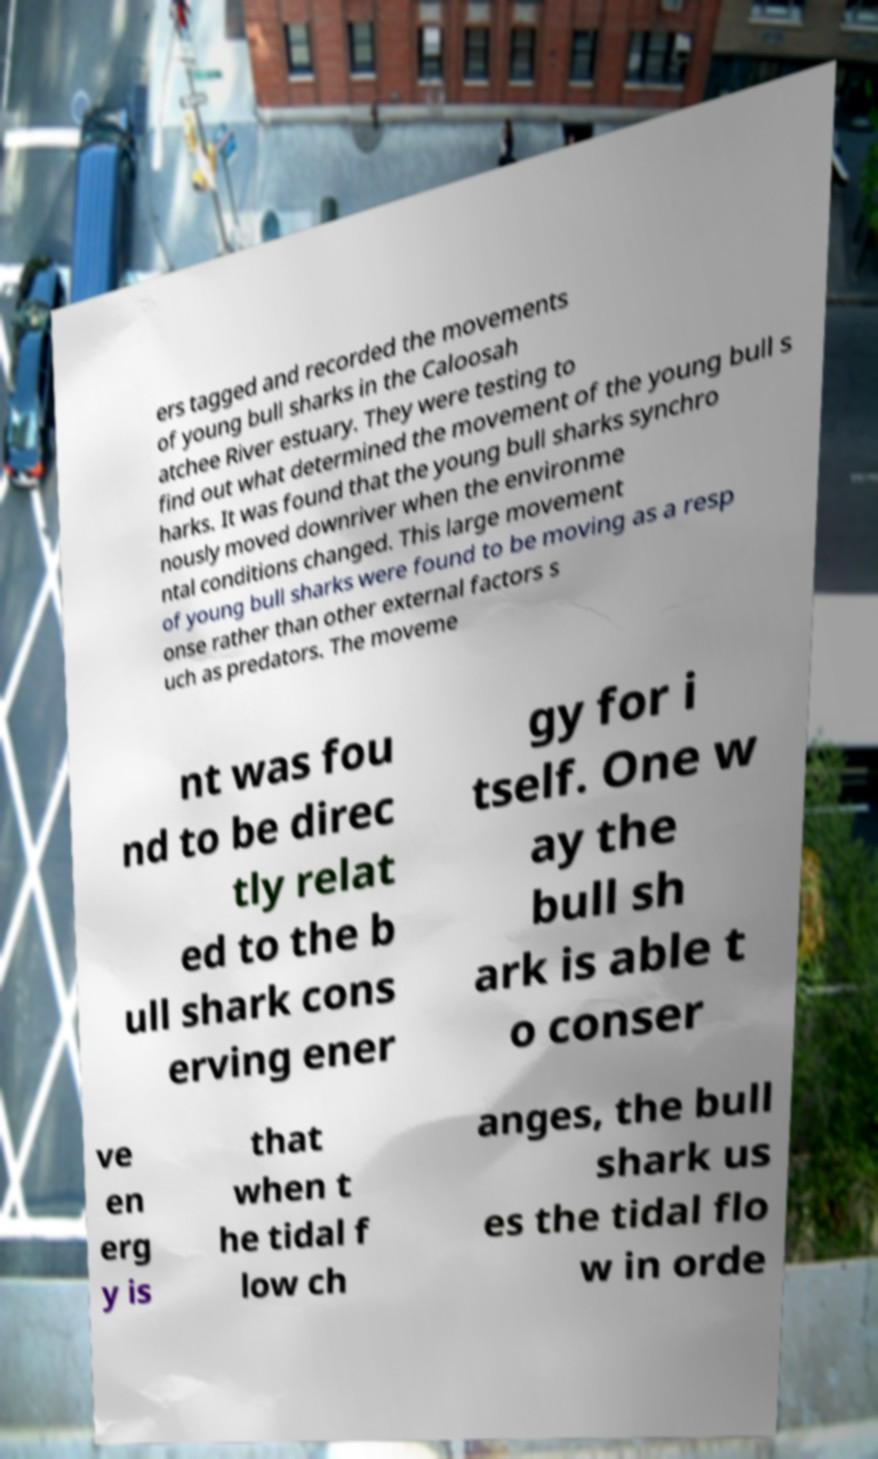Could you extract and type out the text from this image? ers tagged and recorded the movements of young bull sharks in the Caloosah atchee River estuary. They were testing to find out what determined the movement of the young bull s harks. It was found that the young bull sharks synchro nously moved downriver when the environme ntal conditions changed. This large movement of young bull sharks were found to be moving as a resp onse rather than other external factors s uch as predators. The moveme nt was fou nd to be direc tly relat ed to the b ull shark cons erving ener gy for i tself. One w ay the bull sh ark is able t o conser ve en erg y is that when t he tidal f low ch anges, the bull shark us es the tidal flo w in orde 